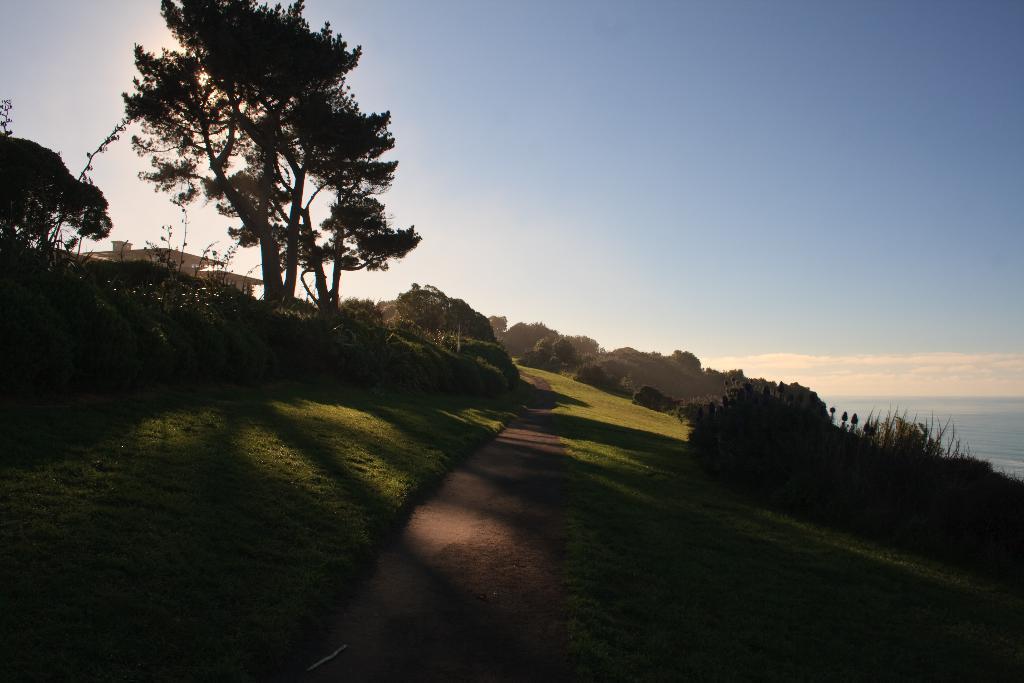Can you describe this image briefly? In the middle of this image, there is a path. On both sides of this path, there are trees, plants and grass on the ground. In the background, there is a building on the ground and there are clouds in the sky. 